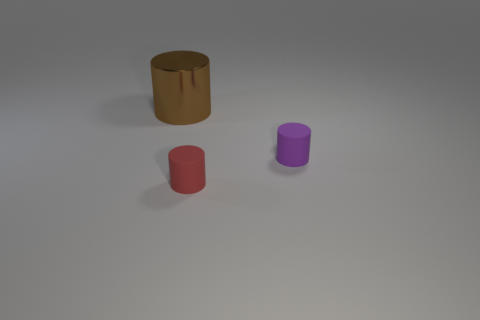Is there anything else that has the same size as the brown shiny thing?
Keep it short and to the point. No. Are there any tiny purple things?
Keep it short and to the point. Yes. What is the material of the brown object that is the same shape as the purple object?
Provide a succinct answer. Metal. There is a big brown object that is behind the tiny thing that is behind the tiny cylinder to the left of the small purple cylinder; what is its shape?
Ensure brevity in your answer.  Cylinder. How many tiny red matte things have the same shape as the metal object?
Keep it short and to the point. 1. There is a tiny object left of the purple matte cylinder; is its color the same as the object right of the small red rubber thing?
Your answer should be compact. No. There is a cylinder that is the same size as the red thing; what is its material?
Provide a short and direct response. Rubber. Is there another purple thing that has the same size as the metal thing?
Ensure brevity in your answer.  No. Is the number of big shiny objects on the left side of the small purple matte thing less than the number of small brown matte things?
Your answer should be compact. No. Are there fewer purple cylinders that are behind the tiny red cylinder than big brown cylinders to the right of the big metal cylinder?
Ensure brevity in your answer.  No. 